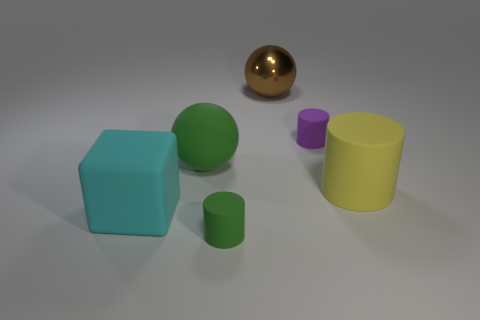There is a block that is the same material as the large yellow object; what color is it?
Keep it short and to the point. Cyan. What color is the rubber sphere?
Offer a very short reply. Green. Do the big cyan cube and the cylinder in front of the yellow object have the same material?
Your answer should be compact. Yes. What number of things are both in front of the large brown shiny thing and to the left of the tiny purple object?
Offer a very short reply. 3. What shape is the cyan rubber thing that is the same size as the green sphere?
Keep it short and to the point. Cube. There is a small cylinder that is behind the big rubber thing that is to the left of the green ball; is there a large thing behind it?
Provide a short and direct response. Yes. There is a cube; is its color the same as the matte cylinder behind the green sphere?
Keep it short and to the point. No. What number of large matte cubes have the same color as the large rubber cylinder?
Offer a terse response. 0. How big is the matte sphere to the left of the tiny cylinder that is behind the big rubber cube?
Make the answer very short. Large. How many things are big cubes that are behind the small green cylinder or large green rubber cubes?
Provide a succinct answer. 1. 